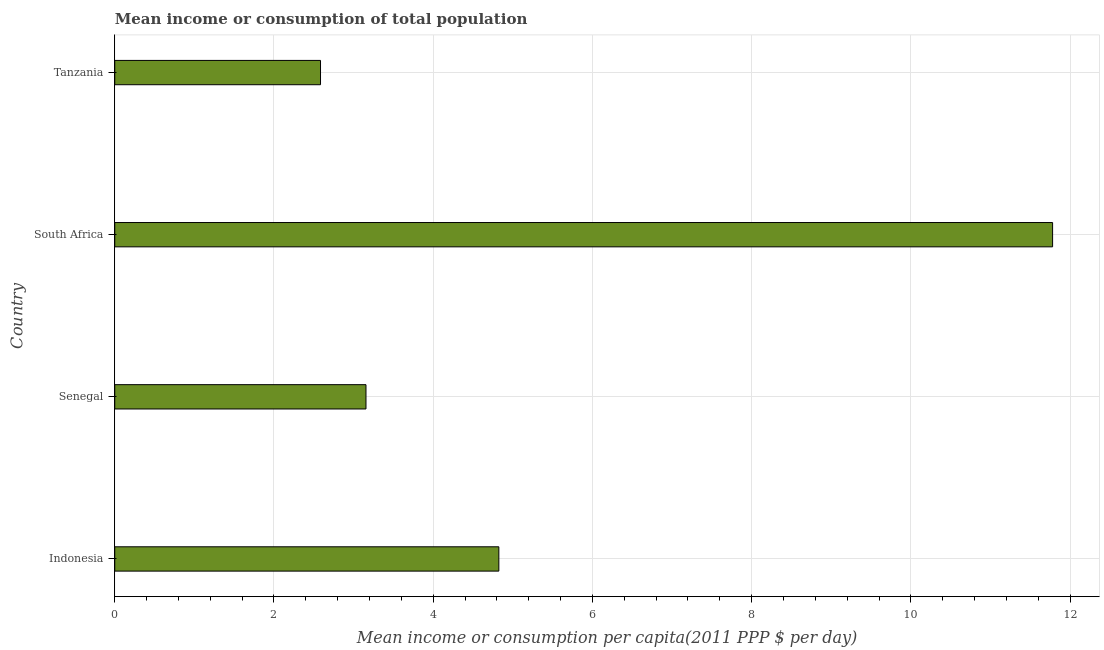Does the graph contain any zero values?
Keep it short and to the point. No. Does the graph contain grids?
Keep it short and to the point. Yes. What is the title of the graph?
Your response must be concise. Mean income or consumption of total population. What is the label or title of the X-axis?
Provide a succinct answer. Mean income or consumption per capita(2011 PPP $ per day). What is the mean income or consumption in South Africa?
Ensure brevity in your answer.  11.78. Across all countries, what is the maximum mean income or consumption?
Offer a very short reply. 11.78. Across all countries, what is the minimum mean income or consumption?
Provide a succinct answer. 2.58. In which country was the mean income or consumption maximum?
Make the answer very short. South Africa. In which country was the mean income or consumption minimum?
Offer a terse response. Tanzania. What is the sum of the mean income or consumption?
Keep it short and to the point. 22.34. What is the difference between the mean income or consumption in Indonesia and Tanzania?
Provide a short and direct response. 2.24. What is the average mean income or consumption per country?
Ensure brevity in your answer.  5.59. What is the median mean income or consumption?
Your answer should be compact. 3.99. What is the ratio of the mean income or consumption in Senegal to that in South Africa?
Your response must be concise. 0.27. Is the mean income or consumption in South Africa less than that in Tanzania?
Your response must be concise. No. What is the difference between the highest and the second highest mean income or consumption?
Your answer should be compact. 6.96. What is the difference between the highest and the lowest mean income or consumption?
Offer a very short reply. 9.2. In how many countries, is the mean income or consumption greater than the average mean income or consumption taken over all countries?
Offer a very short reply. 1. How many countries are there in the graph?
Offer a very short reply. 4. What is the Mean income or consumption per capita(2011 PPP $ per day) in Indonesia?
Provide a short and direct response. 4.82. What is the Mean income or consumption per capita(2011 PPP $ per day) of Senegal?
Ensure brevity in your answer.  3.16. What is the Mean income or consumption per capita(2011 PPP $ per day) in South Africa?
Provide a short and direct response. 11.78. What is the Mean income or consumption per capita(2011 PPP $ per day) of Tanzania?
Your answer should be compact. 2.58. What is the difference between the Mean income or consumption per capita(2011 PPP $ per day) in Indonesia and Senegal?
Make the answer very short. 1.67. What is the difference between the Mean income or consumption per capita(2011 PPP $ per day) in Indonesia and South Africa?
Keep it short and to the point. -6.96. What is the difference between the Mean income or consumption per capita(2011 PPP $ per day) in Indonesia and Tanzania?
Provide a short and direct response. 2.24. What is the difference between the Mean income or consumption per capita(2011 PPP $ per day) in Senegal and South Africa?
Keep it short and to the point. -8.62. What is the difference between the Mean income or consumption per capita(2011 PPP $ per day) in Senegal and Tanzania?
Your response must be concise. 0.57. What is the difference between the Mean income or consumption per capita(2011 PPP $ per day) in South Africa and Tanzania?
Offer a terse response. 9.2. What is the ratio of the Mean income or consumption per capita(2011 PPP $ per day) in Indonesia to that in Senegal?
Offer a terse response. 1.53. What is the ratio of the Mean income or consumption per capita(2011 PPP $ per day) in Indonesia to that in South Africa?
Your answer should be very brief. 0.41. What is the ratio of the Mean income or consumption per capita(2011 PPP $ per day) in Indonesia to that in Tanzania?
Provide a short and direct response. 1.87. What is the ratio of the Mean income or consumption per capita(2011 PPP $ per day) in Senegal to that in South Africa?
Keep it short and to the point. 0.27. What is the ratio of the Mean income or consumption per capita(2011 PPP $ per day) in Senegal to that in Tanzania?
Give a very brief answer. 1.22. What is the ratio of the Mean income or consumption per capita(2011 PPP $ per day) in South Africa to that in Tanzania?
Provide a short and direct response. 4.56. 